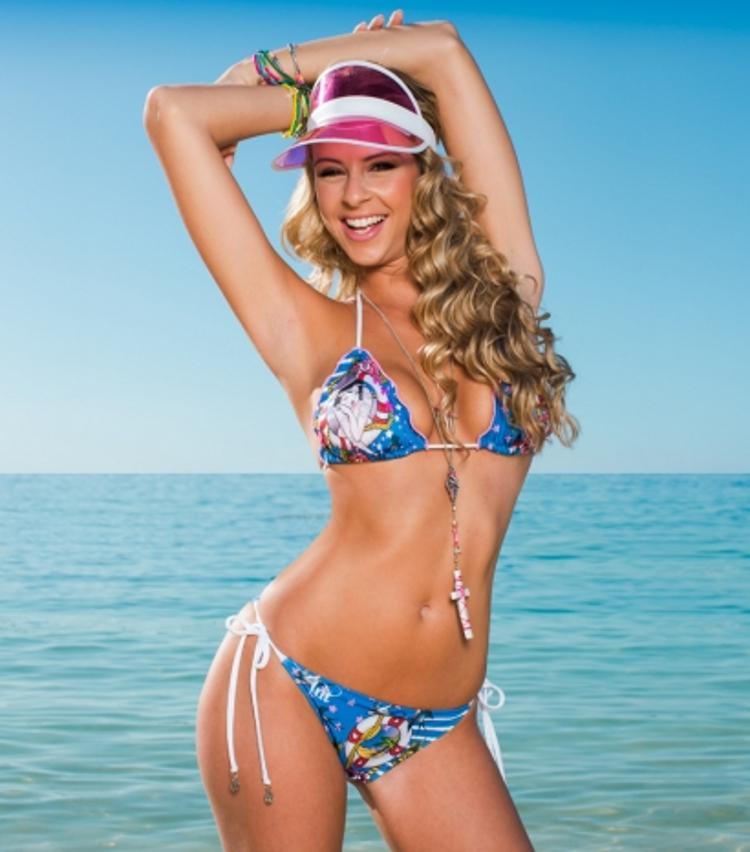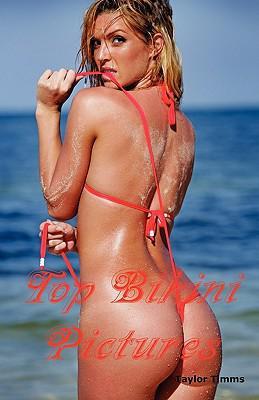The first image is the image on the left, the second image is the image on the right. Assess this claim about the two images: "There is exactly one woman in a swimsuit in each image.". Correct or not? Answer yes or no. Yes. The first image is the image on the left, the second image is the image on the right. Given the left and right images, does the statement "In the left image, the bikini is black." hold true? Answer yes or no. No. 